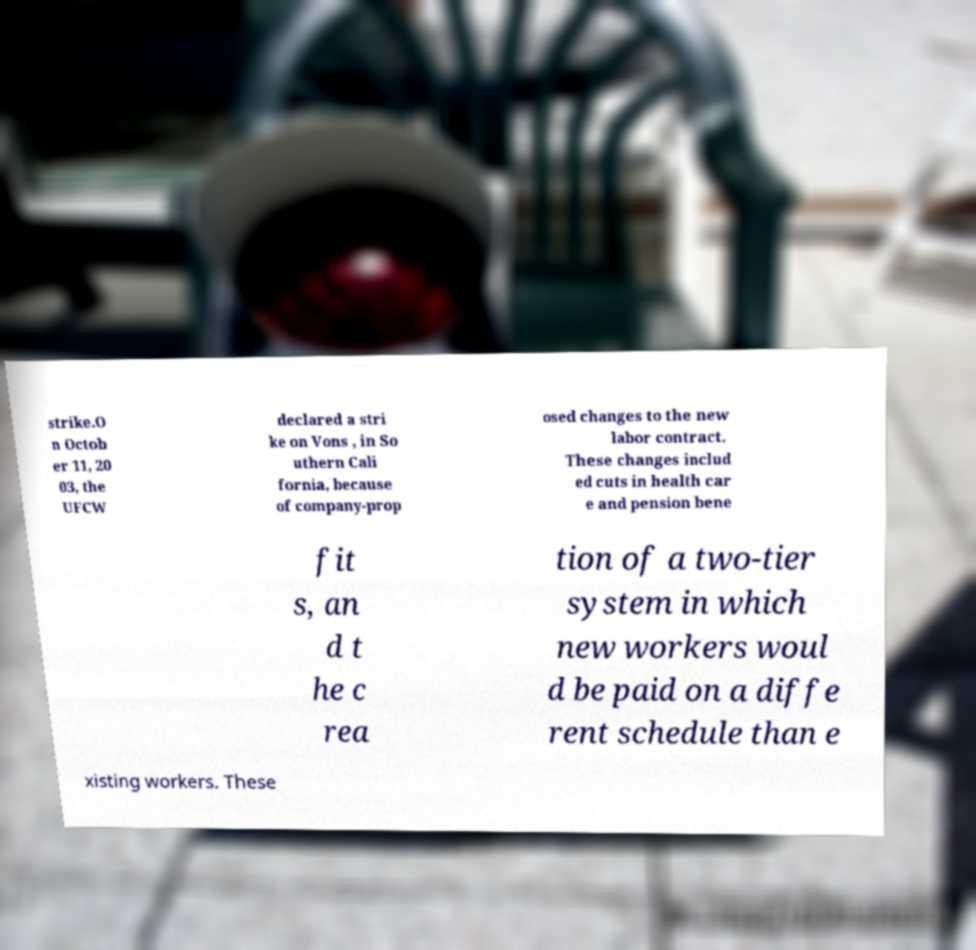There's text embedded in this image that I need extracted. Can you transcribe it verbatim? strike.O n Octob er 11, 20 03, the UFCW declared a stri ke on Vons , in So uthern Cali fornia, because of company-prop osed changes to the new labor contract. These changes includ ed cuts in health car e and pension bene fit s, an d t he c rea tion of a two-tier system in which new workers woul d be paid on a diffe rent schedule than e xisting workers. These 